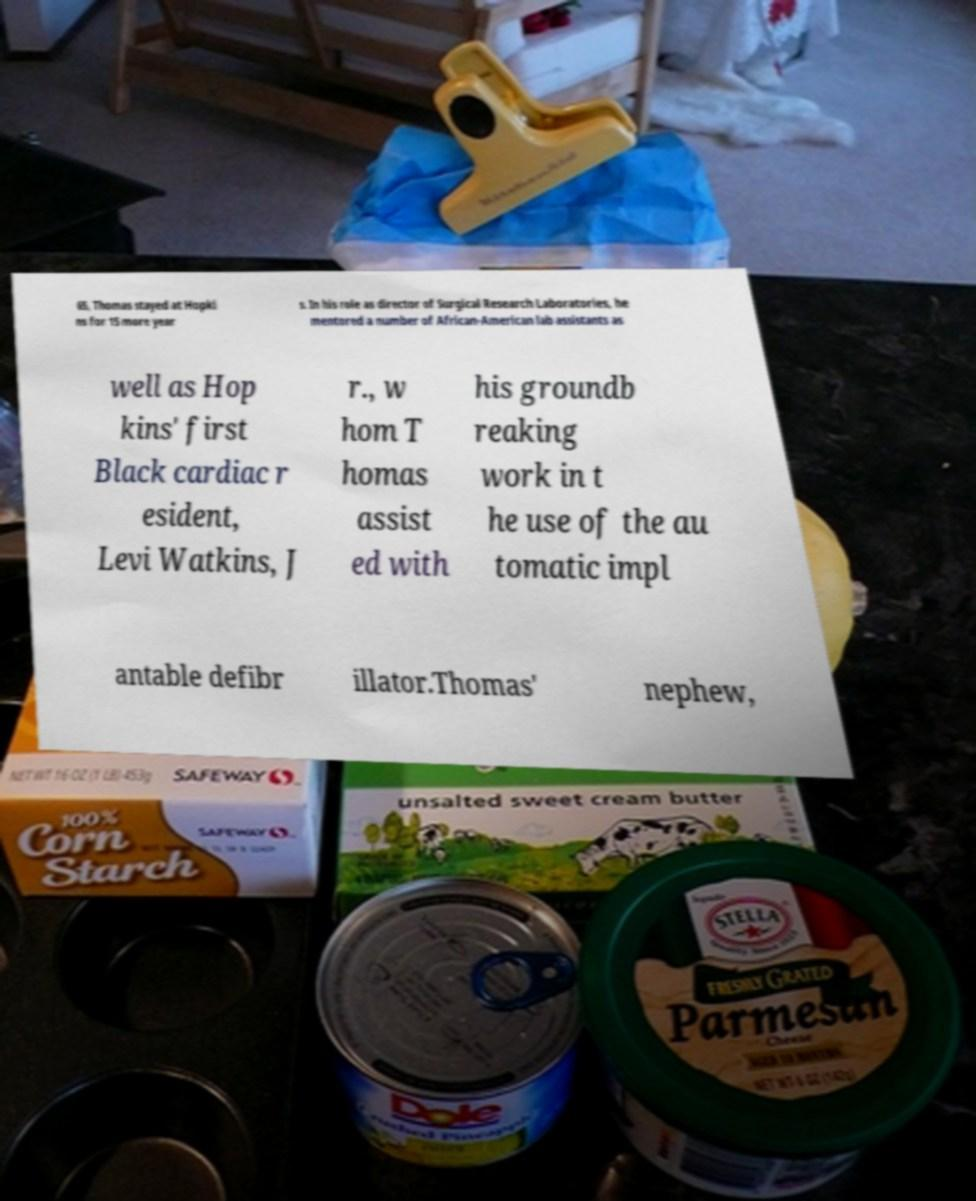Could you extract and type out the text from this image? 65, Thomas stayed at Hopki ns for 15 more year s. In his role as director of Surgical Research Laboratories, he mentored a number of African-American lab assistants as well as Hop kins' first Black cardiac r esident, Levi Watkins, J r., w hom T homas assist ed with his groundb reaking work in t he use of the au tomatic impl antable defibr illator.Thomas' nephew, 